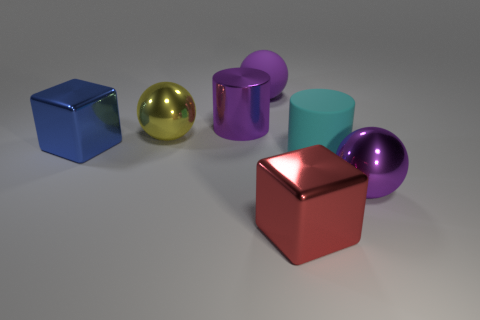The large ball that is made of the same material as the cyan cylinder is what color?
Ensure brevity in your answer.  Purple. Do the red metal thing in front of the big purple cylinder and the yellow metal object have the same shape?
Provide a short and direct response. No. There is another object that is the same shape as the cyan rubber object; what color is it?
Offer a very short reply. Purple. There is a blue metal thing; is its shape the same as the big purple object to the right of the big red metallic object?
Your response must be concise. No. What is the size of the purple rubber thing that is the same shape as the big yellow object?
Your answer should be very brief. Large. What number of other things are made of the same material as the blue cube?
Offer a terse response. 4. Do the big yellow sphere and the purple ball that is in front of the big matte sphere have the same material?
Provide a succinct answer. Yes. Are there fewer big red metallic cubes behind the large matte sphere than purple rubber balls behind the rubber cylinder?
Offer a very short reply. Yes. What is the color of the metal block on the right side of the metallic cylinder?
Your answer should be very brief. Red. What number of other things are there of the same color as the rubber sphere?
Keep it short and to the point. 2. 